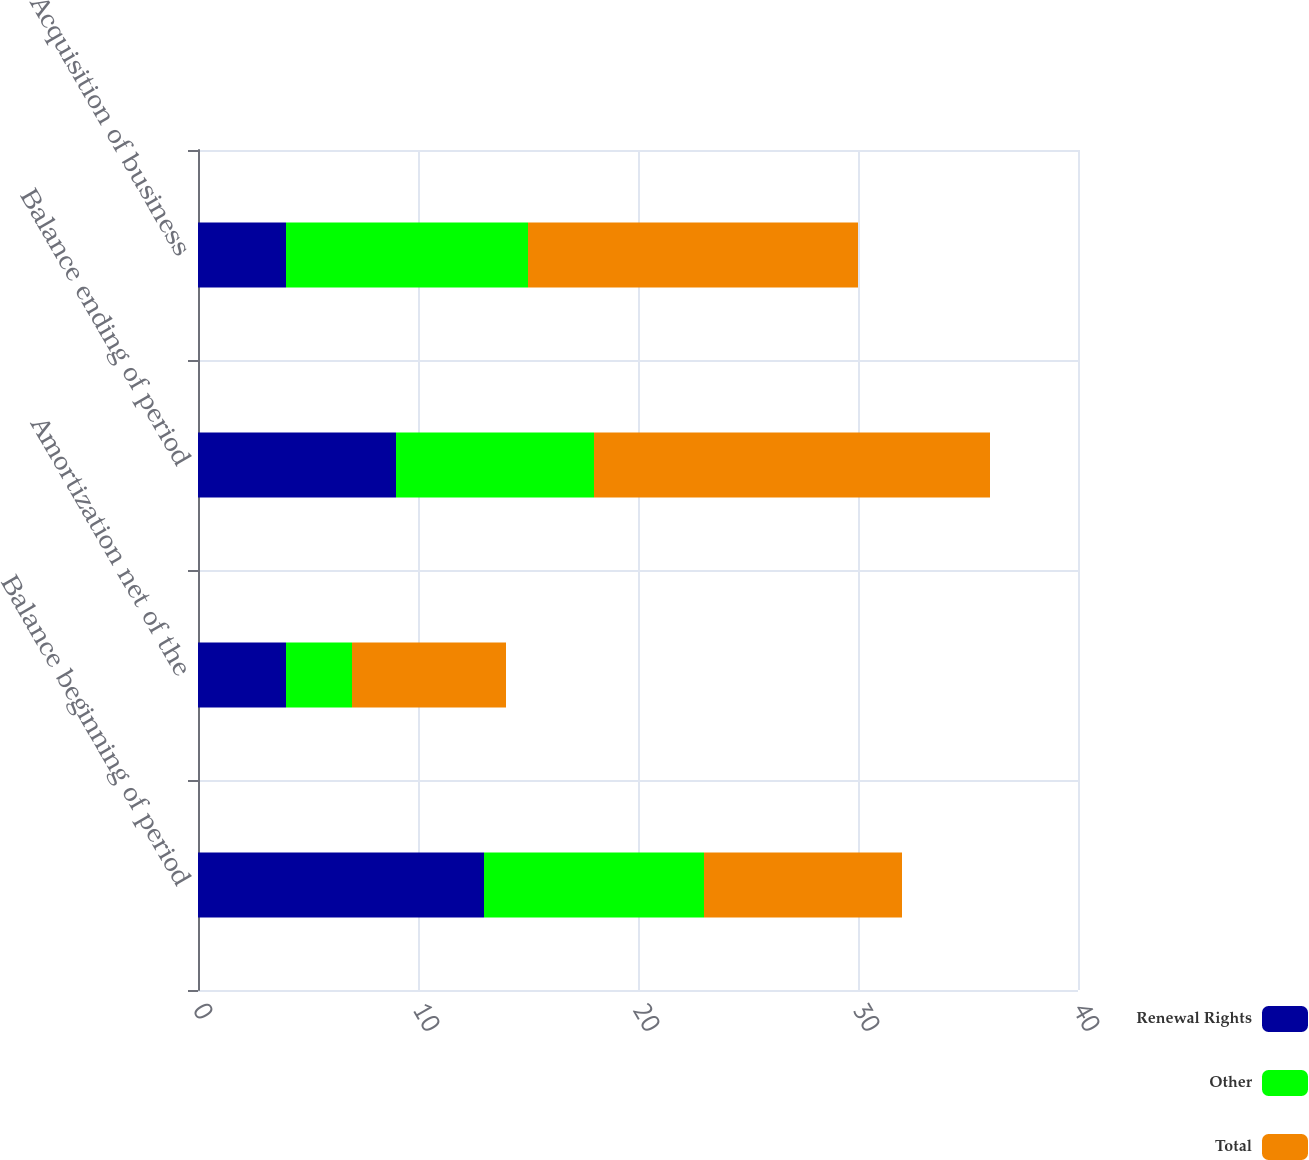<chart> <loc_0><loc_0><loc_500><loc_500><stacked_bar_chart><ecel><fcel>Balance beginning of period<fcel>Amortization net of the<fcel>Balance ending of period<fcel>Acquisition of business<nl><fcel>Renewal Rights<fcel>13<fcel>4<fcel>9<fcel>4<nl><fcel>Other<fcel>10<fcel>3<fcel>9<fcel>11<nl><fcel>Total<fcel>9<fcel>7<fcel>18<fcel>15<nl></chart> 